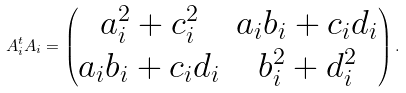<formula> <loc_0><loc_0><loc_500><loc_500>A _ { i } ^ { t } A _ { i } = \left ( \begin{matrix} a _ { i } ^ { 2 } + c _ { i } ^ { 2 } & a _ { i } b _ { i } + c _ { i } d _ { i } \\ a _ { i } b _ { i } + c _ { i } d _ { i } & b _ { i } ^ { 2 } + d _ { i } ^ { 2 } \end{matrix} \right ) .</formula> 